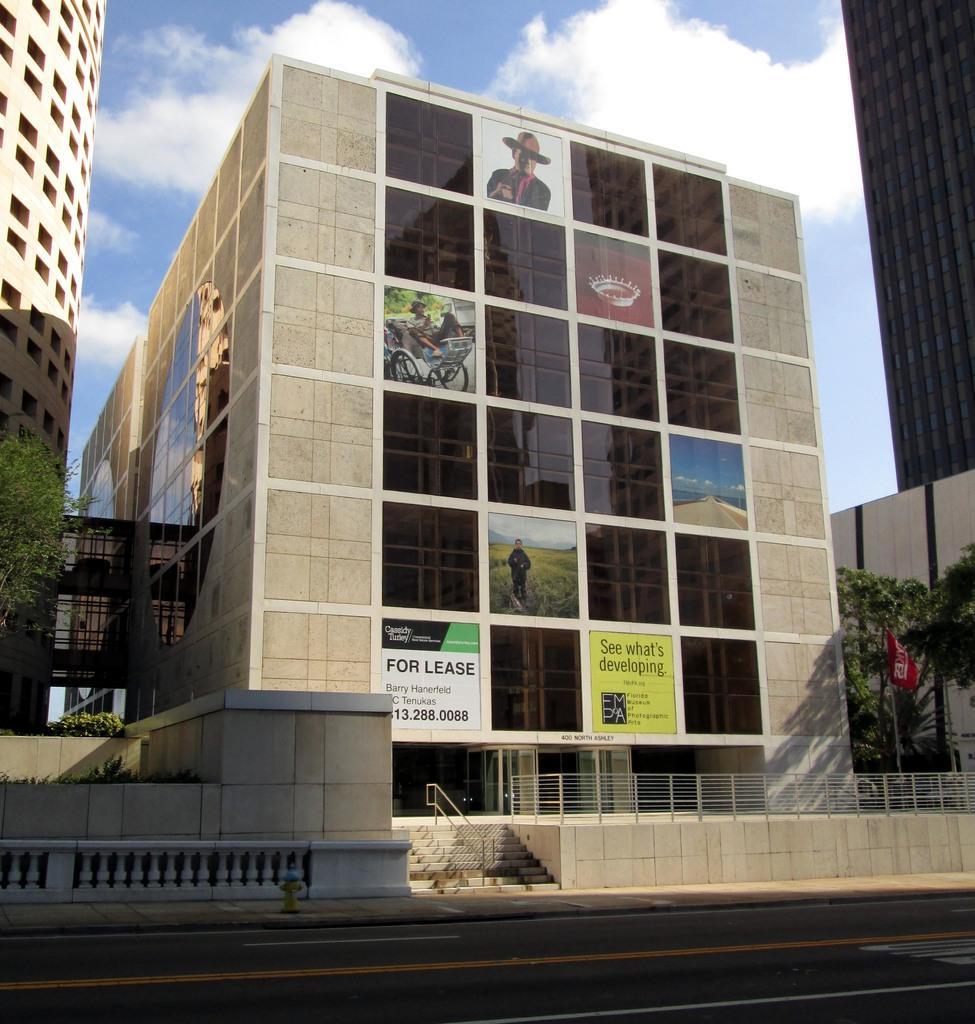How would you summarize this image in a sentence or two? Here we can see buildings, boards, glasses, and trees. This is a fence and there is a flag. In the background we can see sky with clouds. 